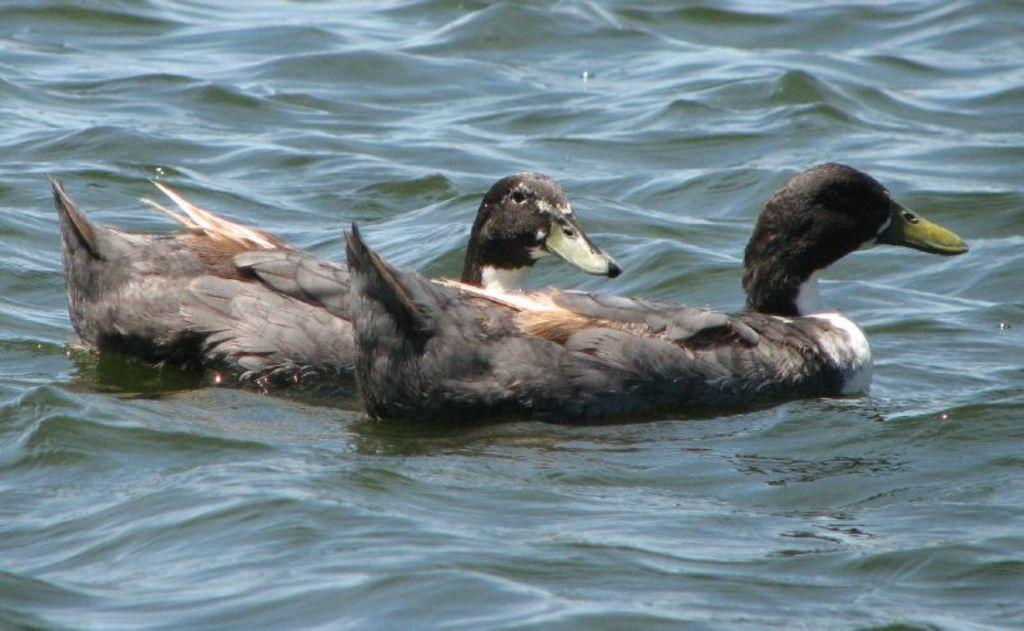What type of animals can be seen in the image? Birds can be seen in the image. What colors are the birds in the image? The birds are in black, brown, and white colors. What territory do the birds claim as their own in the image? There is no indication in the image that the birds are claiming any territory as their own. 